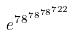<formula> <loc_0><loc_0><loc_500><loc_500>e ^ { 7 8 ^ { 7 8 ^ { 7 8 ^ { 7 2 2 } } } }</formula> 